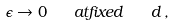Convert formula to latex. <formula><loc_0><loc_0><loc_500><loc_500>\epsilon \to 0 \quad a t f i x e d \quad d \, ,</formula> 